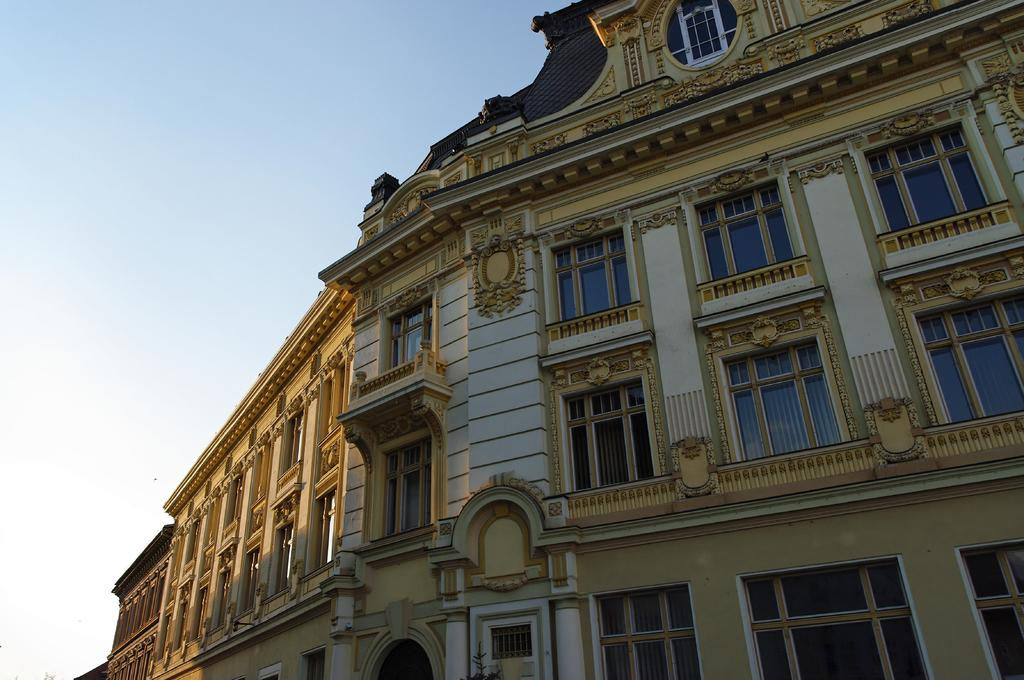What type of structure is present in the image? There is a building in the image. What can be seen in the background of the image? The sky is visible in the background of the image. How many teeth can be seen in the image? There are no teeth visible in the image. What is the current status of the building in the image? The provided facts do not mention any information about the current status of the building, so it cannot be determined from the image. 